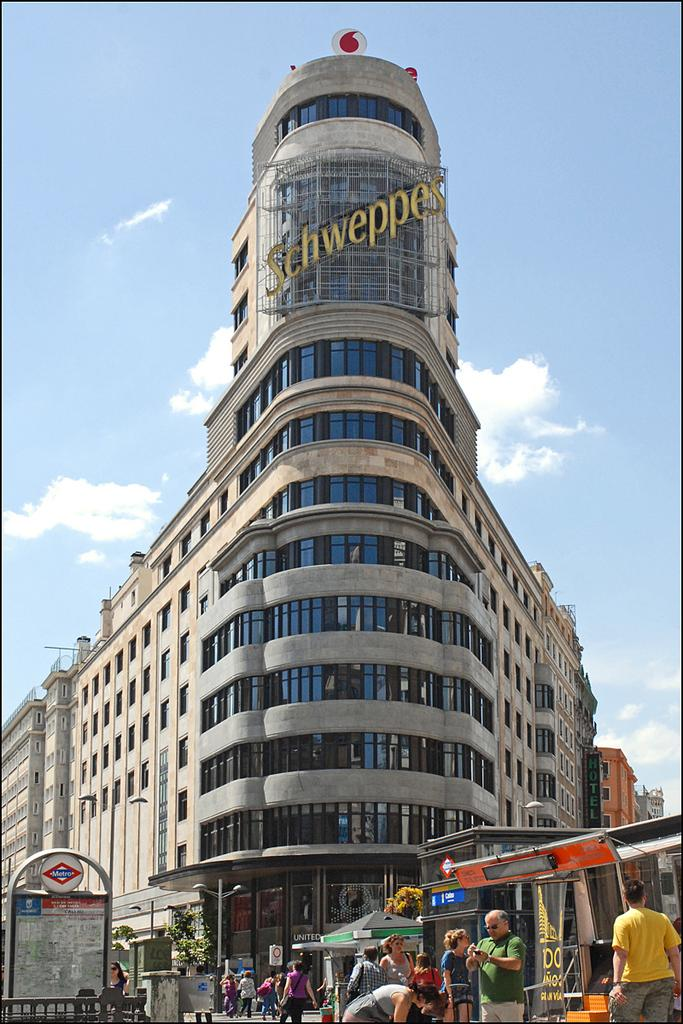Who or what can be seen in the image? There are people in the image. Where are the people located? The people are standing on the street. What else is visible in the image besides the people? There is a building in the image. How far away is the farm from the people in the image? There is no farm present in the image, so it is not possible to determine the distance between the people and a farm. 